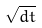<formula> <loc_0><loc_0><loc_500><loc_500>\sqrt { d t }</formula> 